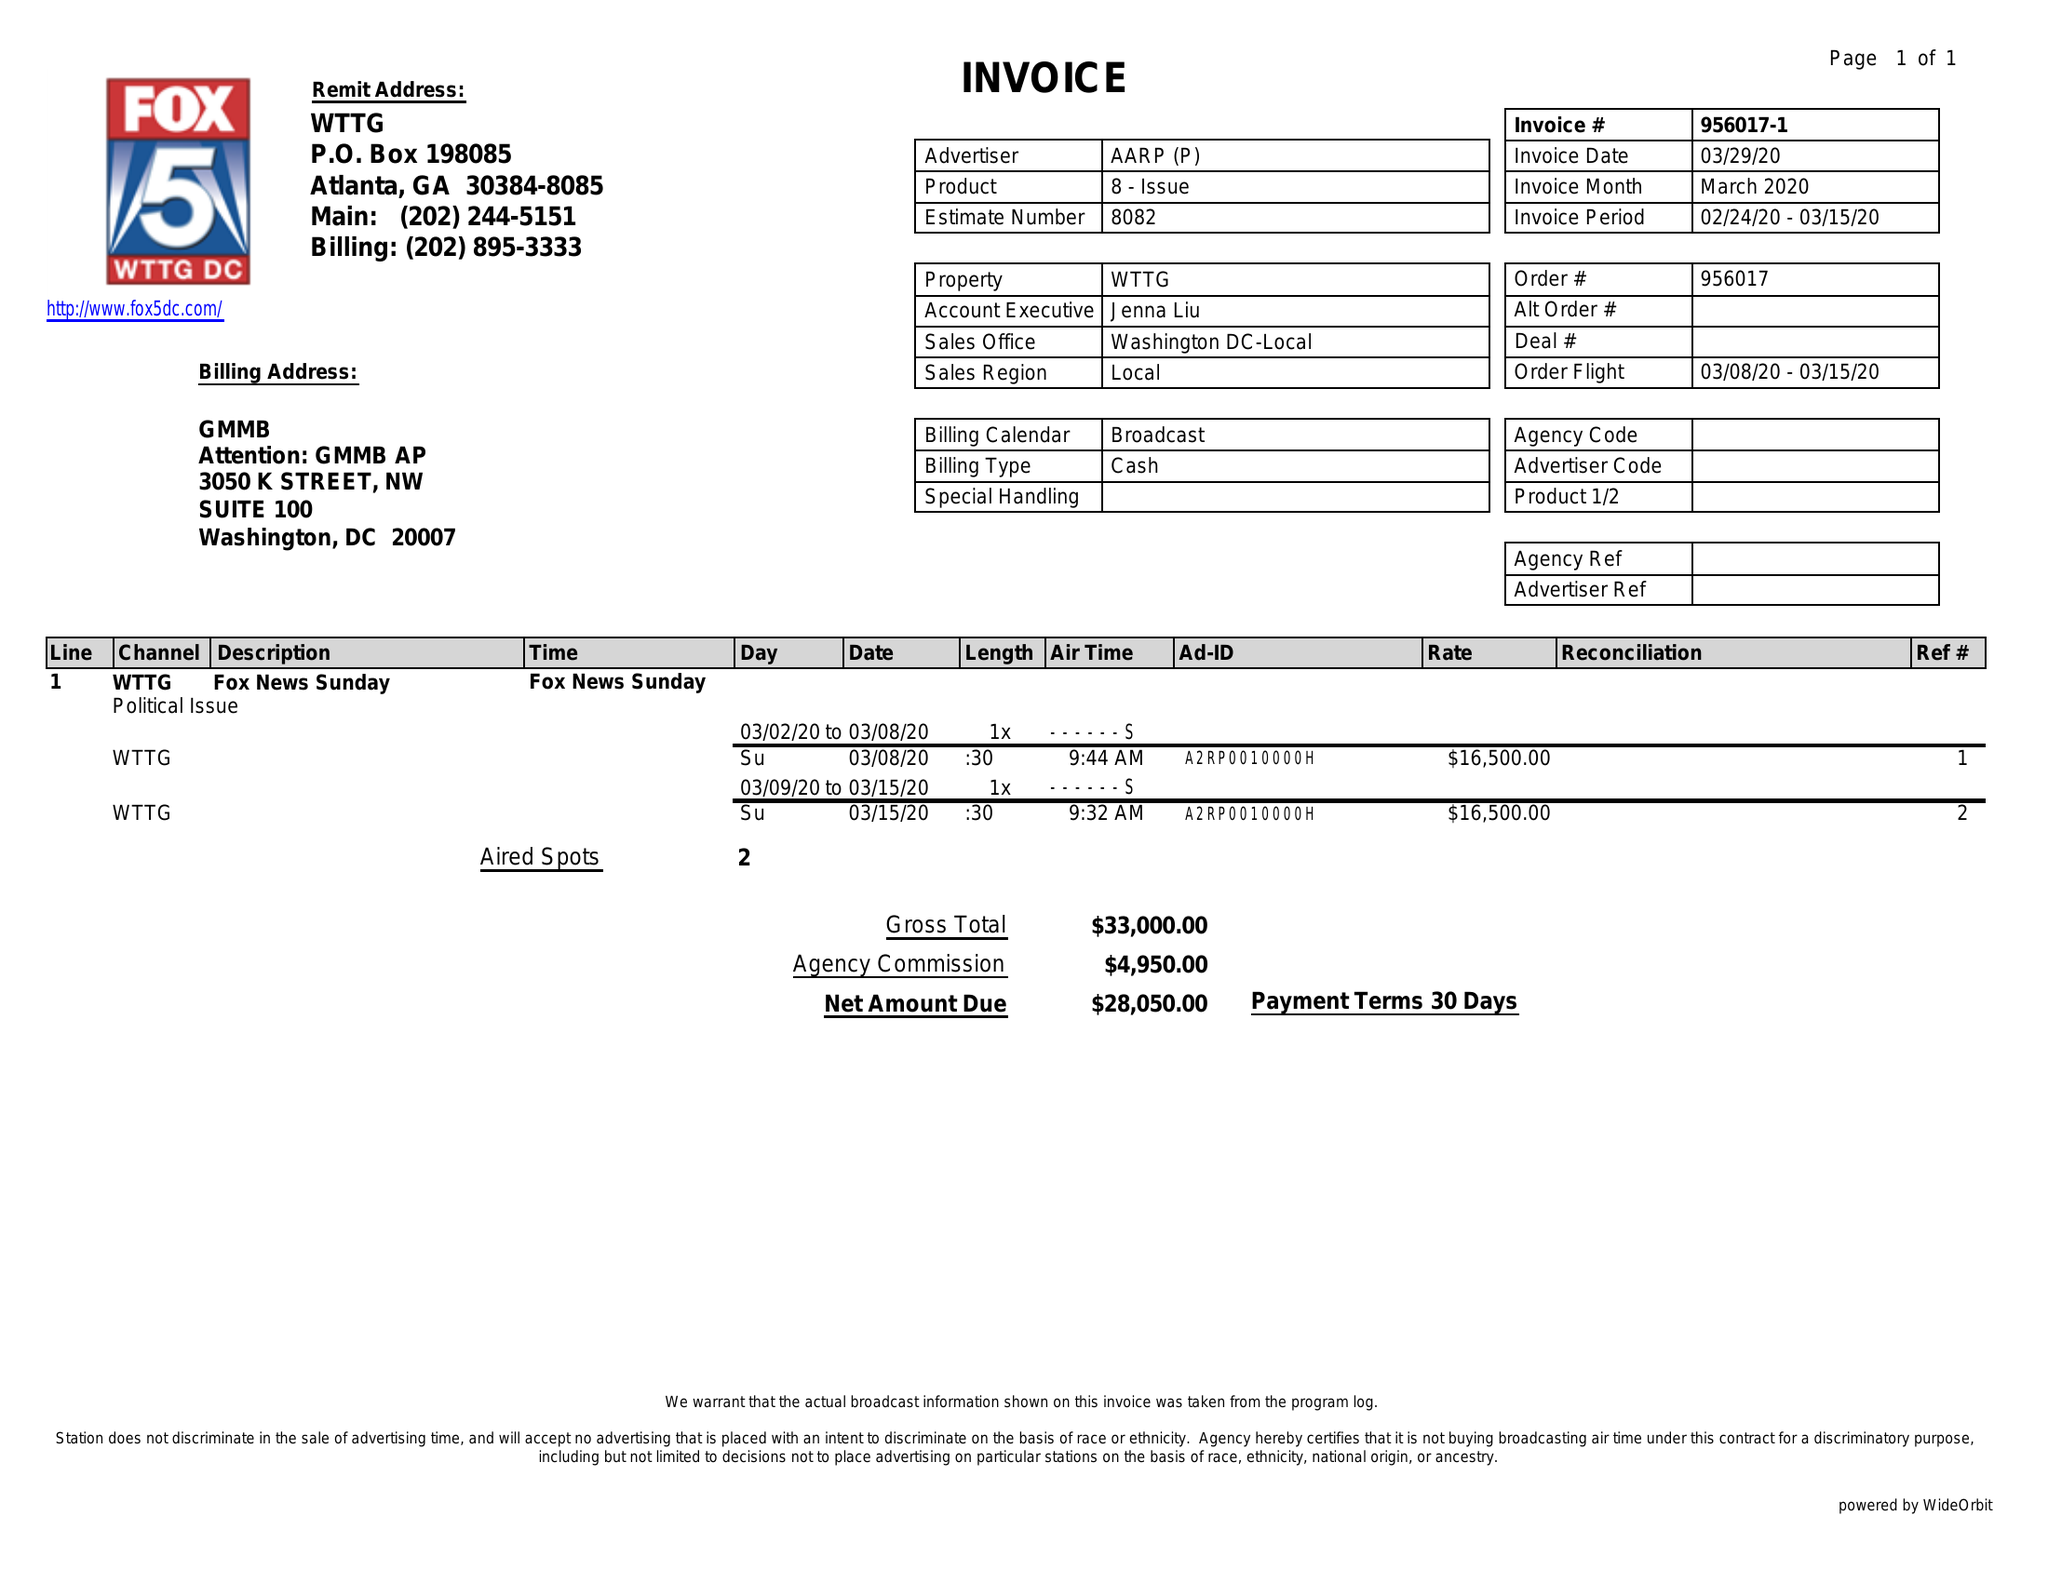What is the value for the flight_from?
Answer the question using a single word or phrase. 03/08/20 